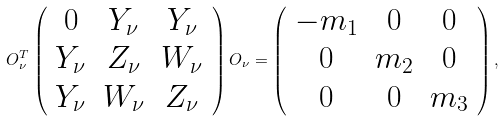Convert formula to latex. <formula><loc_0><loc_0><loc_500><loc_500>O _ { \nu } ^ { T } \left ( \begin{array} { c c c } 0 & Y _ { \nu } & Y _ { \nu } \\ Y _ { \nu } & Z _ { \nu } & W _ { \nu } \\ Y _ { \nu } & W _ { \nu } & Z _ { \nu } \end{array} \right ) O _ { \nu } = \left ( \begin{array} { c c c } - m _ { 1 } & 0 & 0 \\ 0 & m _ { 2 } & 0 \\ 0 & 0 & m _ { 3 } \end{array} \right ) ,</formula> 